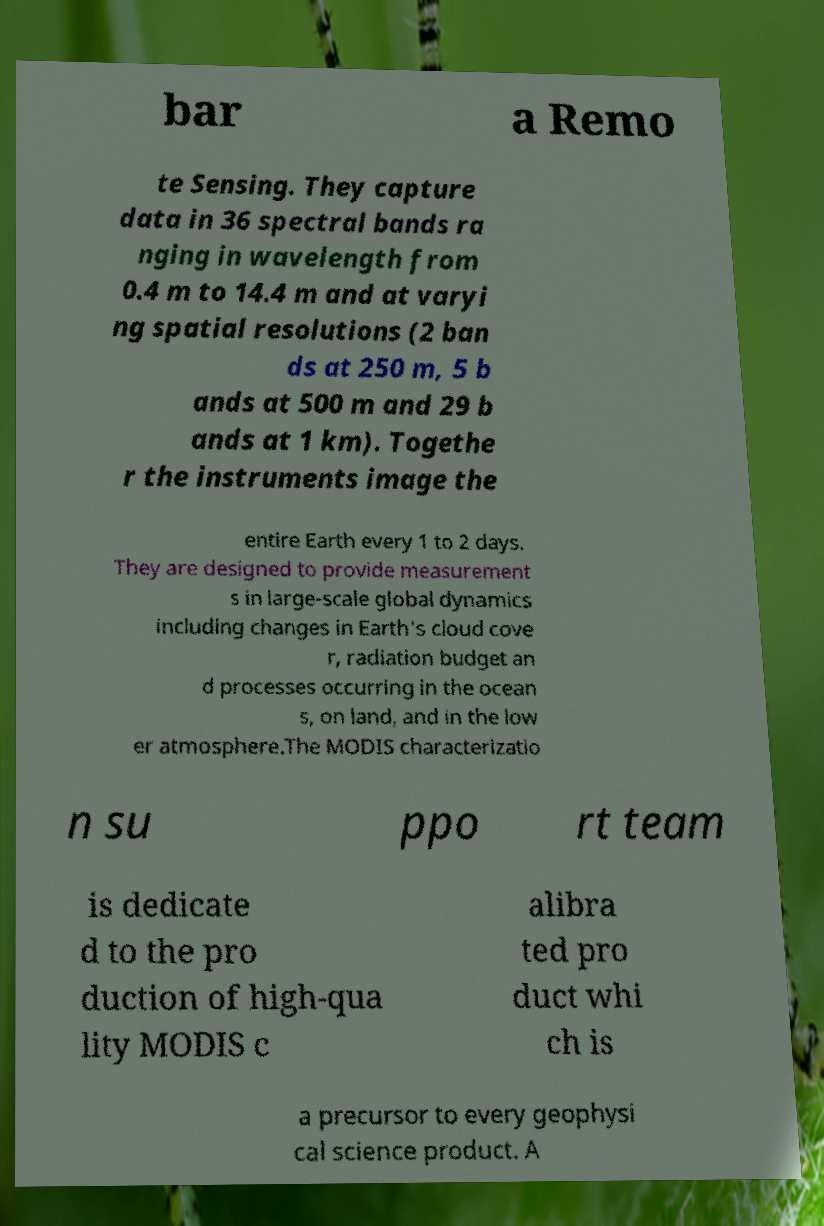Could you extract and type out the text from this image? bar a Remo te Sensing. They capture data in 36 spectral bands ra nging in wavelength from 0.4 m to 14.4 m and at varyi ng spatial resolutions (2 ban ds at 250 m, 5 b ands at 500 m and 29 b ands at 1 km). Togethe r the instruments image the entire Earth every 1 to 2 days. They are designed to provide measurement s in large-scale global dynamics including changes in Earth's cloud cove r, radiation budget an d processes occurring in the ocean s, on land, and in the low er atmosphere.The MODIS characterizatio n su ppo rt team is dedicate d to the pro duction of high-qua lity MODIS c alibra ted pro duct whi ch is a precursor to every geophysi cal science product. A 